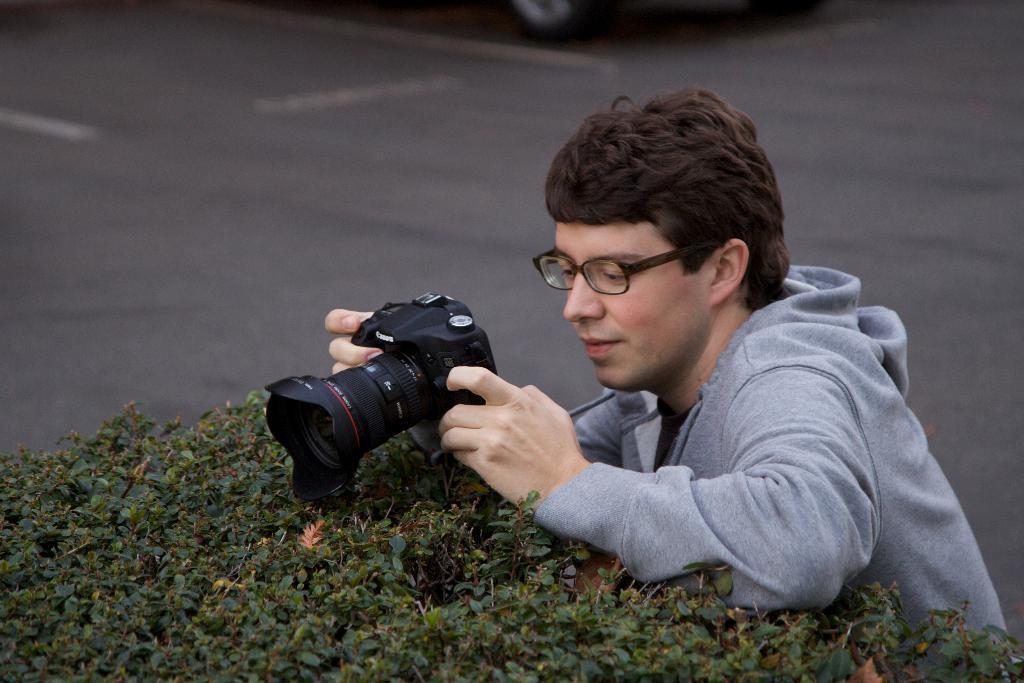How would you summarize this image in a sentence or two? In this picture there is a man wearing a spectacles, holding a camera in his hand, clicking a picture. In the background there is a road. We can observe some plants here. 